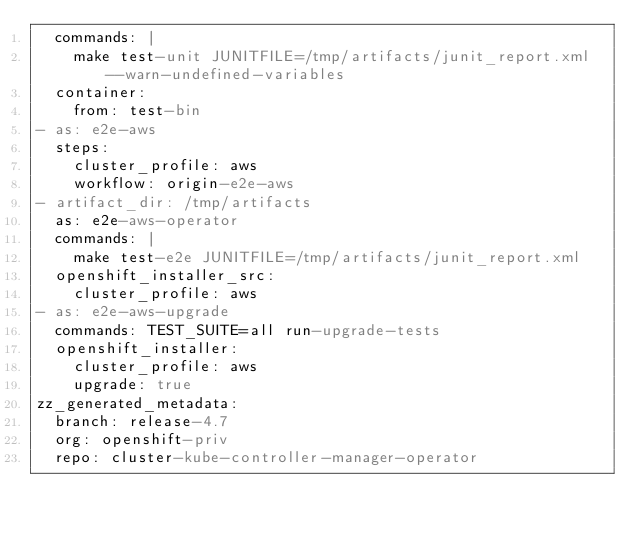Convert code to text. <code><loc_0><loc_0><loc_500><loc_500><_YAML_>  commands: |
    make test-unit JUNITFILE=/tmp/artifacts/junit_report.xml --warn-undefined-variables
  container:
    from: test-bin
- as: e2e-aws
  steps:
    cluster_profile: aws
    workflow: origin-e2e-aws
- artifact_dir: /tmp/artifacts
  as: e2e-aws-operator
  commands: |
    make test-e2e JUNITFILE=/tmp/artifacts/junit_report.xml
  openshift_installer_src:
    cluster_profile: aws
- as: e2e-aws-upgrade
  commands: TEST_SUITE=all run-upgrade-tests
  openshift_installer:
    cluster_profile: aws
    upgrade: true
zz_generated_metadata:
  branch: release-4.7
  org: openshift-priv
  repo: cluster-kube-controller-manager-operator
</code> 